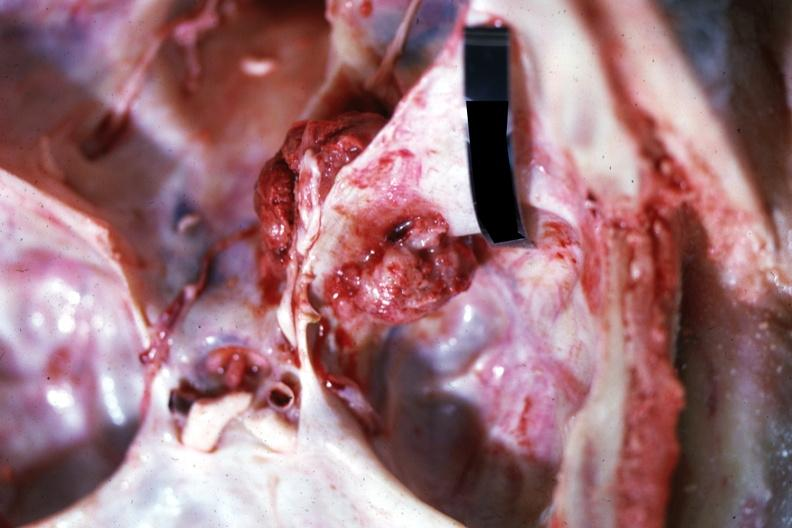what does this image show?
Answer the question using a single word or phrase. Close-up view of meaty appearing metastatic lesion in temporal and posterior fossa 